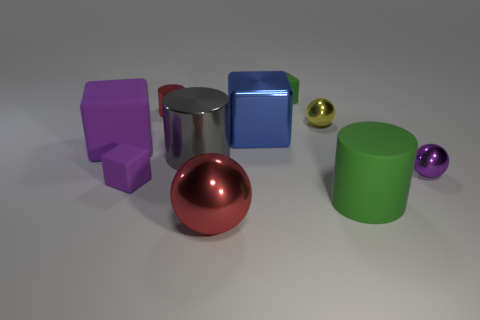What textures are visible on the objects, and do they suggest anything about the materials? The objects display a variety of textures: the red sphere and blue cube are highly reflective, suggesting metallic materials, while the purple and green objects have a matte finish, indicative of a rubber or plastic material. 